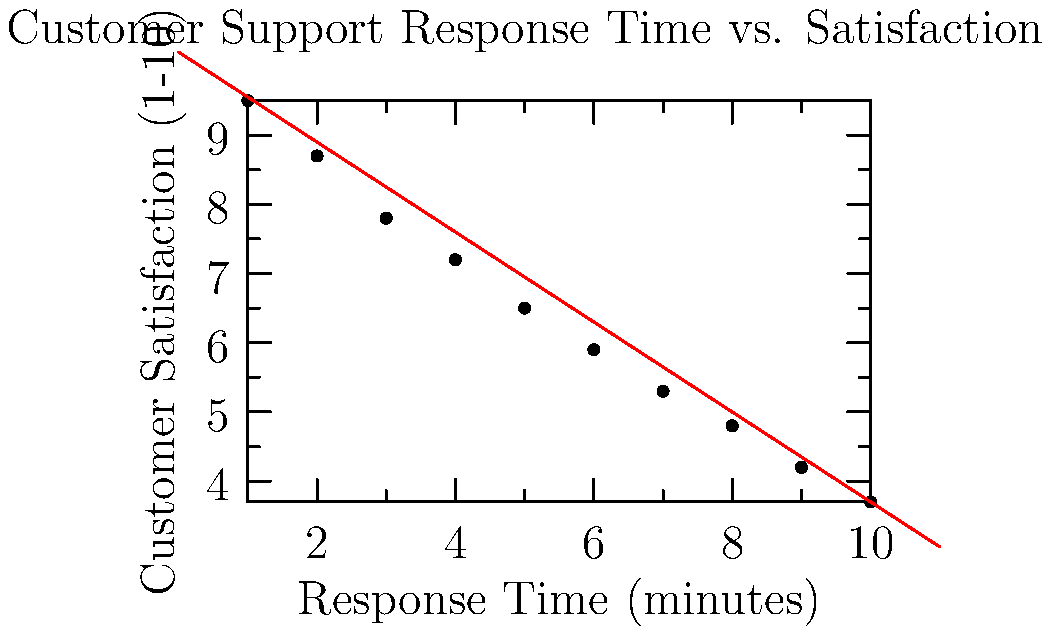Based on the scatter plot showing the relationship between customer support response time and customer satisfaction, what can be inferred about the correlation between these two variables? Additionally, estimate the expected customer satisfaction score for a response time of 5 minutes. To answer this question, let's analyze the scatter plot step by step:

1. Correlation analysis:
   - The points in the scatter plot show a clear downward trend from left to right.
   - As the response time (x-axis) increases, the customer satisfaction score (y-axis) decreases.
   - This indicates a negative correlation between response time and customer satisfaction.

2. Strength of correlation:
   - The points closely follow the red trend line, with minimal scatter.
   - This suggests a strong negative correlation between the two variables.

3. Linearity:
   - The relationship appears to be approximately linear, as evidenced by the good fit of the linear trend line.

4. Estimating customer satisfaction for a 5-minute response time:
   - Locate the point on the x-axis corresponding to 5 minutes.
   - Draw a vertical line up to the trend line.
   - From the intersection point, draw a horizontal line to the y-axis.
   - The y-value at this point is approximately 6.5.

5. Equation of the trend line:
   - The trend line can be described by the equation $y = -0.65x + 10.2$, where:
     $y$ is the customer satisfaction score
     $x$ is the response time in minutes
   - Using this equation, we can calculate the exact expected satisfaction score for a 5-minute response time:
     $y = -0.65 * 5 + 10.2 = 6.95$

In conclusion, there is a strong negative linear correlation between customer support response time and customer satisfaction. As response time increases, customer satisfaction decreases. For a response time of 5 minutes, the expected customer satisfaction score is approximately 6.95 on a scale of 1-10.
Answer: Strong negative correlation; satisfaction score ≈ 6.95 for 5-minute response time 